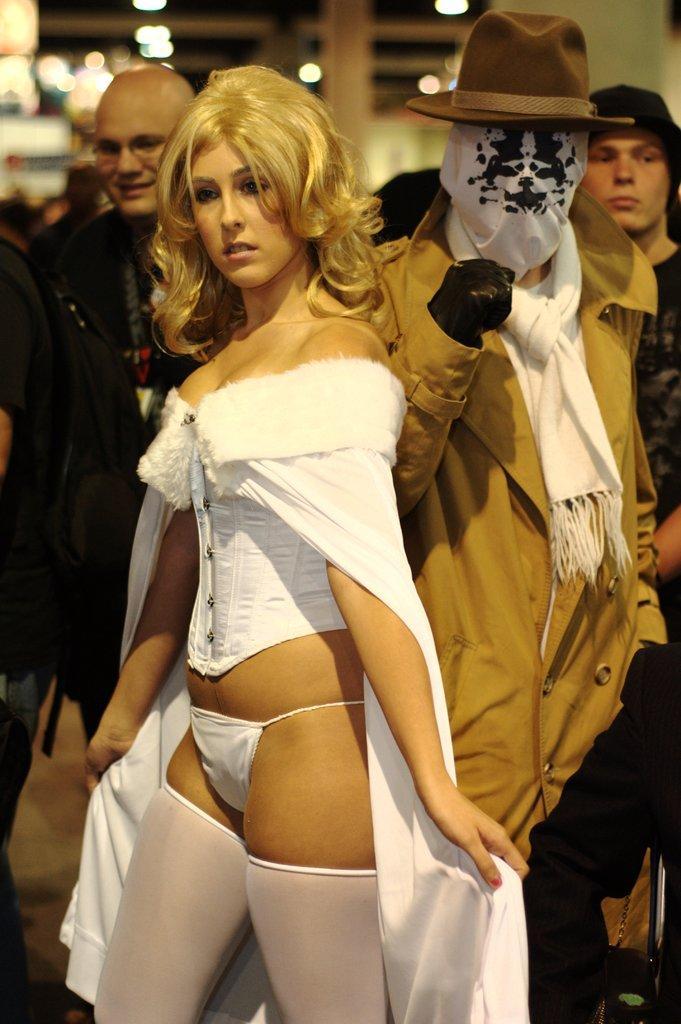Please provide a concise description of this image. In this picture we can see a group of people standing. Behind the people, there are some blurred objects. 